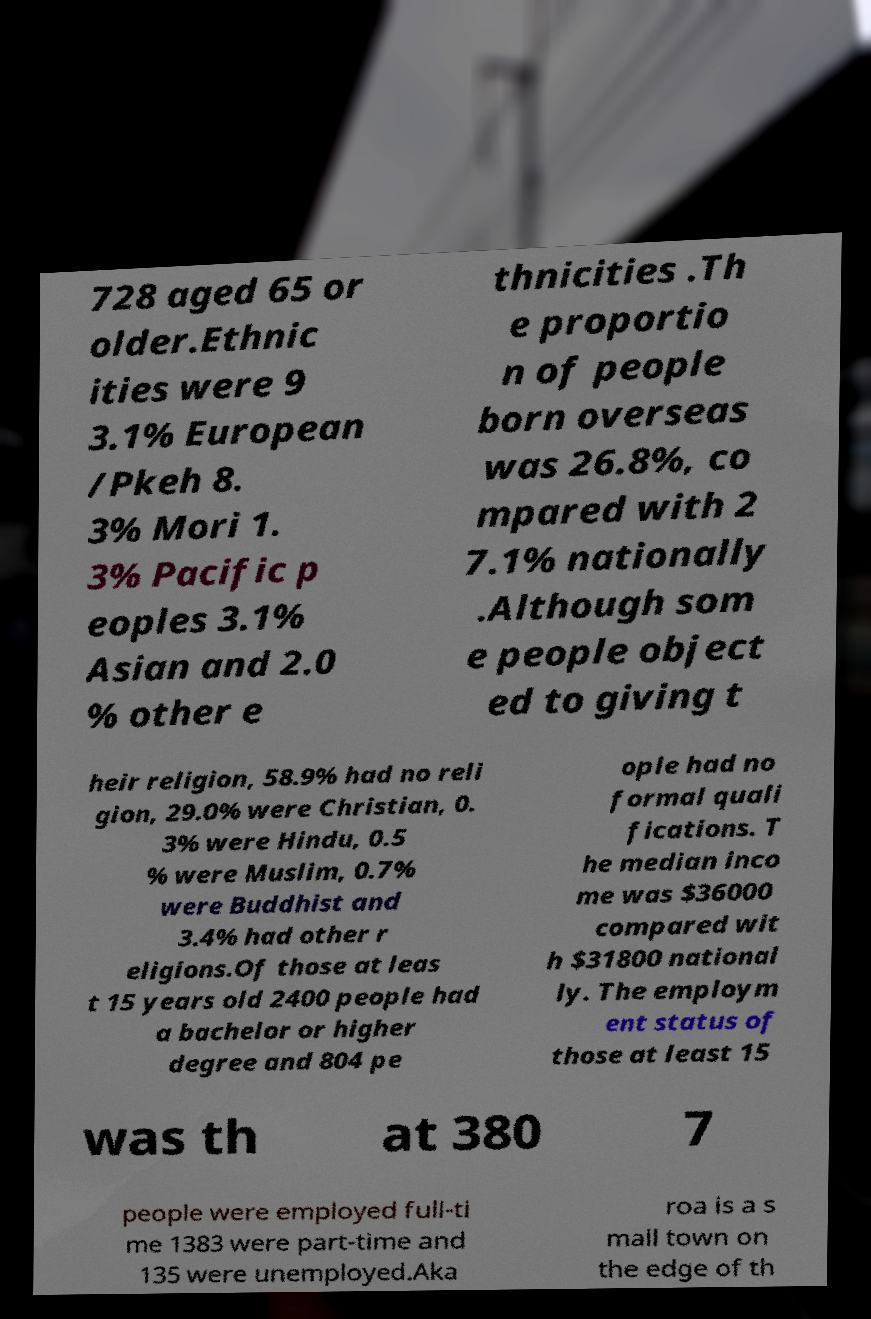Please read and relay the text visible in this image. What does it say? 728 aged 65 or older.Ethnic ities were 9 3.1% European /Pkeh 8. 3% Mori 1. 3% Pacific p eoples 3.1% Asian and 2.0 % other e thnicities .Th e proportio n of people born overseas was 26.8%, co mpared with 2 7.1% nationally .Although som e people object ed to giving t heir religion, 58.9% had no reli gion, 29.0% were Christian, 0. 3% were Hindu, 0.5 % were Muslim, 0.7% were Buddhist and 3.4% had other r eligions.Of those at leas t 15 years old 2400 people had a bachelor or higher degree and 804 pe ople had no formal quali fications. T he median inco me was $36000 compared wit h $31800 national ly. The employm ent status of those at least 15 was th at 380 7 people were employed full-ti me 1383 were part-time and 135 were unemployed.Aka roa is a s mall town on the edge of th 